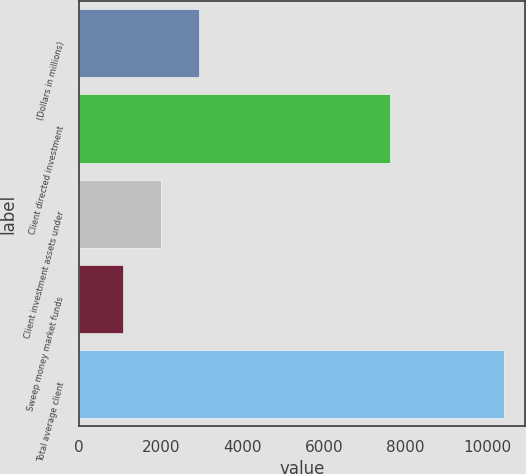Convert chart. <chart><loc_0><loc_0><loc_500><loc_500><bar_chart><fcel>(Dollars in millions)<fcel>Client directed investment<fcel>Client investment assets under<fcel>Sweep money market funds<fcel>Total average client<nl><fcel>2934.8<fcel>7624<fcel>2000.9<fcel>1067<fcel>10406<nl></chart> 